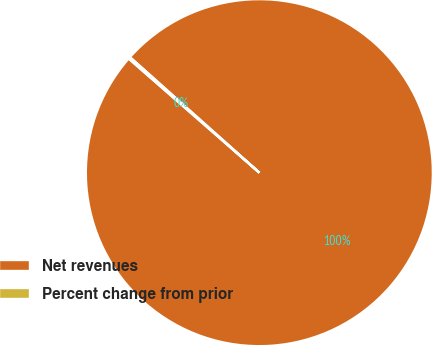Convert chart. <chart><loc_0><loc_0><loc_500><loc_500><pie_chart><fcel>Net revenues<fcel>Percent change from prior<nl><fcel>99.83%<fcel>0.17%<nl></chart> 